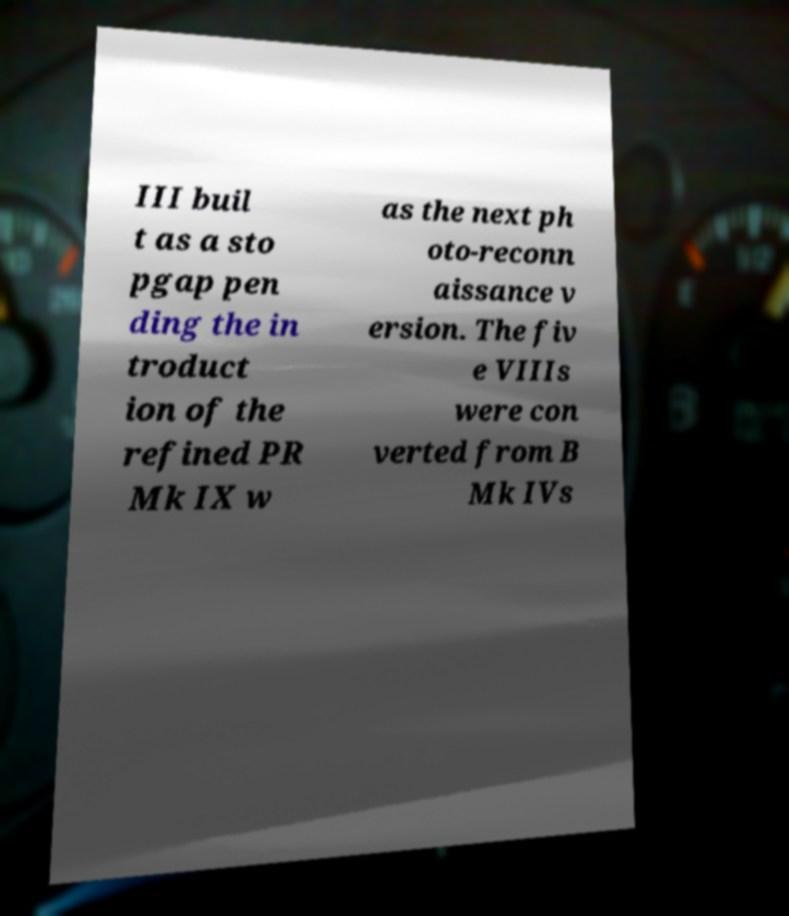Can you accurately transcribe the text from the provided image for me? III buil t as a sto pgap pen ding the in troduct ion of the refined PR Mk IX w as the next ph oto-reconn aissance v ersion. The fiv e VIIIs were con verted from B Mk IVs 